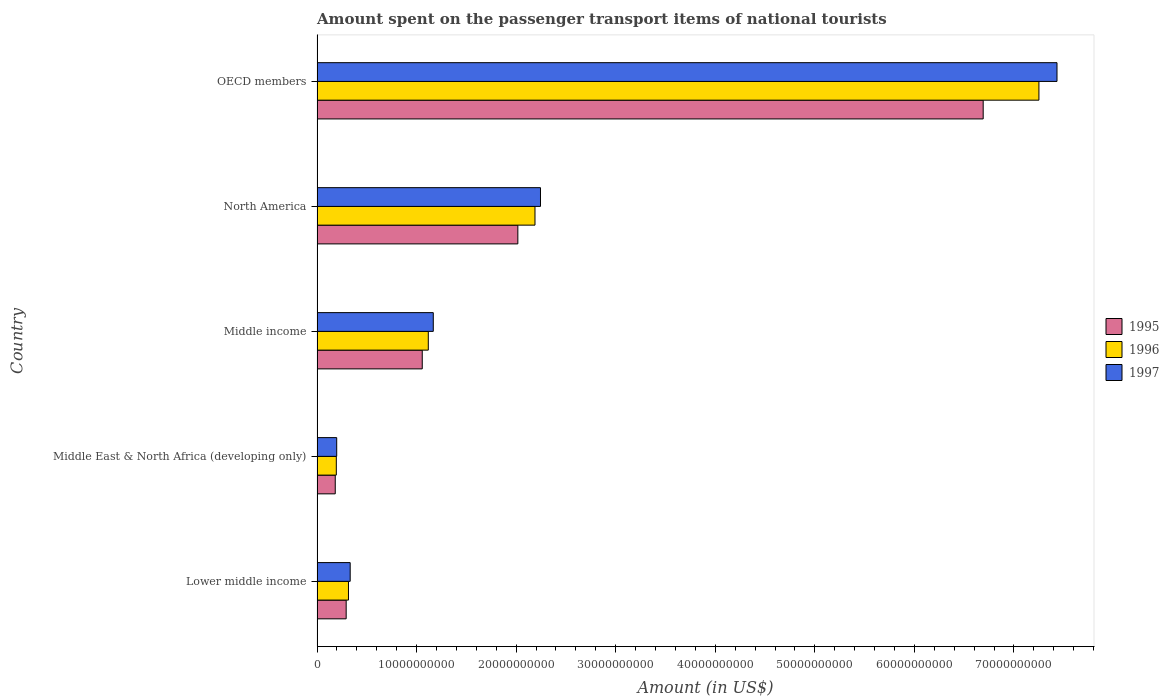How many groups of bars are there?
Your response must be concise. 5. Are the number of bars on each tick of the Y-axis equal?
Make the answer very short. Yes. How many bars are there on the 1st tick from the top?
Your answer should be very brief. 3. How many bars are there on the 5th tick from the bottom?
Give a very brief answer. 3. What is the label of the 5th group of bars from the top?
Offer a terse response. Lower middle income. In how many cases, is the number of bars for a given country not equal to the number of legend labels?
Make the answer very short. 0. What is the amount spent on the passenger transport items of national tourists in 1996 in North America?
Keep it short and to the point. 2.19e+1. Across all countries, what is the maximum amount spent on the passenger transport items of national tourists in 1997?
Ensure brevity in your answer.  7.43e+1. Across all countries, what is the minimum amount spent on the passenger transport items of national tourists in 1996?
Offer a very short reply. 1.94e+09. In which country was the amount spent on the passenger transport items of national tourists in 1997 maximum?
Your response must be concise. OECD members. In which country was the amount spent on the passenger transport items of national tourists in 1997 minimum?
Your answer should be very brief. Middle East & North Africa (developing only). What is the total amount spent on the passenger transport items of national tourists in 1997 in the graph?
Make the answer very short. 1.14e+11. What is the difference between the amount spent on the passenger transport items of national tourists in 1995 in Lower middle income and that in Middle income?
Your answer should be compact. -7.64e+09. What is the difference between the amount spent on the passenger transport items of national tourists in 1997 in Middle income and the amount spent on the passenger transport items of national tourists in 1996 in North America?
Give a very brief answer. -1.02e+1. What is the average amount spent on the passenger transport items of national tourists in 1996 per country?
Ensure brevity in your answer.  2.21e+1. What is the difference between the amount spent on the passenger transport items of national tourists in 1996 and amount spent on the passenger transport items of national tourists in 1997 in Middle income?
Make the answer very short. -5.01e+08. What is the ratio of the amount spent on the passenger transport items of national tourists in 1995 in Middle East & North Africa (developing only) to that in OECD members?
Your answer should be compact. 0.03. Is the difference between the amount spent on the passenger transport items of national tourists in 1996 in Middle income and North America greater than the difference between the amount spent on the passenger transport items of national tourists in 1997 in Middle income and North America?
Provide a succinct answer. Yes. What is the difference between the highest and the second highest amount spent on the passenger transport items of national tourists in 1996?
Give a very brief answer. 5.06e+1. What is the difference between the highest and the lowest amount spent on the passenger transport items of national tourists in 1995?
Make the answer very short. 6.51e+1. What does the 2nd bar from the top in Lower middle income represents?
Your answer should be compact. 1996. What does the 3rd bar from the bottom in Lower middle income represents?
Your answer should be very brief. 1997. Is it the case that in every country, the sum of the amount spent on the passenger transport items of national tourists in 1997 and amount spent on the passenger transport items of national tourists in 1996 is greater than the amount spent on the passenger transport items of national tourists in 1995?
Your answer should be very brief. Yes. How many bars are there?
Your response must be concise. 15. Are all the bars in the graph horizontal?
Offer a very short reply. Yes. How many countries are there in the graph?
Provide a succinct answer. 5. What is the difference between two consecutive major ticks on the X-axis?
Offer a very short reply. 1.00e+1. Are the values on the major ticks of X-axis written in scientific E-notation?
Provide a short and direct response. No. Does the graph contain grids?
Give a very brief answer. No. Where does the legend appear in the graph?
Your answer should be very brief. Center right. How many legend labels are there?
Provide a short and direct response. 3. How are the legend labels stacked?
Your answer should be very brief. Vertical. What is the title of the graph?
Provide a succinct answer. Amount spent on the passenger transport items of national tourists. Does "2003" appear as one of the legend labels in the graph?
Keep it short and to the point. No. What is the Amount (in US$) of 1995 in Lower middle income?
Your answer should be very brief. 2.92e+09. What is the Amount (in US$) in 1996 in Lower middle income?
Give a very brief answer. 3.16e+09. What is the Amount (in US$) of 1997 in Lower middle income?
Provide a short and direct response. 3.33e+09. What is the Amount (in US$) in 1995 in Middle East & North Africa (developing only)?
Offer a very short reply. 1.83e+09. What is the Amount (in US$) in 1996 in Middle East & North Africa (developing only)?
Make the answer very short. 1.94e+09. What is the Amount (in US$) in 1997 in Middle East & North Africa (developing only)?
Provide a short and direct response. 1.97e+09. What is the Amount (in US$) of 1995 in Middle income?
Provide a short and direct response. 1.06e+1. What is the Amount (in US$) in 1996 in Middle income?
Offer a terse response. 1.12e+1. What is the Amount (in US$) of 1997 in Middle income?
Provide a short and direct response. 1.17e+1. What is the Amount (in US$) in 1995 in North America?
Provide a succinct answer. 2.02e+1. What is the Amount (in US$) in 1996 in North America?
Your response must be concise. 2.19e+1. What is the Amount (in US$) of 1997 in North America?
Your response must be concise. 2.24e+1. What is the Amount (in US$) in 1995 in OECD members?
Your answer should be compact. 6.69e+1. What is the Amount (in US$) in 1996 in OECD members?
Give a very brief answer. 7.25e+1. What is the Amount (in US$) in 1997 in OECD members?
Provide a succinct answer. 7.43e+1. Across all countries, what is the maximum Amount (in US$) of 1995?
Keep it short and to the point. 6.69e+1. Across all countries, what is the maximum Amount (in US$) in 1996?
Make the answer very short. 7.25e+1. Across all countries, what is the maximum Amount (in US$) of 1997?
Provide a short and direct response. 7.43e+1. Across all countries, what is the minimum Amount (in US$) in 1995?
Offer a terse response. 1.83e+09. Across all countries, what is the minimum Amount (in US$) of 1996?
Give a very brief answer. 1.94e+09. Across all countries, what is the minimum Amount (in US$) in 1997?
Provide a succinct answer. 1.97e+09. What is the total Amount (in US$) in 1995 in the graph?
Provide a short and direct response. 1.02e+11. What is the total Amount (in US$) of 1996 in the graph?
Your answer should be very brief. 1.11e+11. What is the total Amount (in US$) in 1997 in the graph?
Offer a very short reply. 1.14e+11. What is the difference between the Amount (in US$) of 1995 in Lower middle income and that in Middle East & North Africa (developing only)?
Give a very brief answer. 1.10e+09. What is the difference between the Amount (in US$) in 1996 in Lower middle income and that in Middle East & North Africa (developing only)?
Provide a succinct answer. 1.22e+09. What is the difference between the Amount (in US$) in 1997 in Lower middle income and that in Middle East & North Africa (developing only)?
Give a very brief answer. 1.35e+09. What is the difference between the Amount (in US$) in 1995 in Lower middle income and that in Middle income?
Provide a short and direct response. -7.64e+09. What is the difference between the Amount (in US$) of 1996 in Lower middle income and that in Middle income?
Your response must be concise. -8.02e+09. What is the difference between the Amount (in US$) of 1997 in Lower middle income and that in Middle income?
Your answer should be very brief. -8.35e+09. What is the difference between the Amount (in US$) in 1995 in Lower middle income and that in North America?
Make the answer very short. -1.72e+1. What is the difference between the Amount (in US$) of 1996 in Lower middle income and that in North America?
Ensure brevity in your answer.  -1.87e+1. What is the difference between the Amount (in US$) in 1997 in Lower middle income and that in North America?
Make the answer very short. -1.91e+1. What is the difference between the Amount (in US$) in 1995 in Lower middle income and that in OECD members?
Your response must be concise. -6.40e+1. What is the difference between the Amount (in US$) of 1996 in Lower middle income and that in OECD members?
Ensure brevity in your answer.  -6.94e+1. What is the difference between the Amount (in US$) in 1997 in Lower middle income and that in OECD members?
Keep it short and to the point. -7.10e+1. What is the difference between the Amount (in US$) in 1995 in Middle East & North Africa (developing only) and that in Middle income?
Your answer should be compact. -8.74e+09. What is the difference between the Amount (in US$) in 1996 in Middle East & North Africa (developing only) and that in Middle income?
Ensure brevity in your answer.  -9.24e+09. What is the difference between the Amount (in US$) of 1997 in Middle East & North Africa (developing only) and that in Middle income?
Offer a very short reply. -9.70e+09. What is the difference between the Amount (in US$) in 1995 in Middle East & North Africa (developing only) and that in North America?
Offer a terse response. -1.83e+1. What is the difference between the Amount (in US$) of 1996 in Middle East & North Africa (developing only) and that in North America?
Ensure brevity in your answer.  -2.00e+1. What is the difference between the Amount (in US$) of 1997 in Middle East & North Africa (developing only) and that in North America?
Your answer should be compact. -2.05e+1. What is the difference between the Amount (in US$) of 1995 in Middle East & North Africa (developing only) and that in OECD members?
Offer a very short reply. -6.51e+1. What is the difference between the Amount (in US$) in 1996 in Middle East & North Africa (developing only) and that in OECD members?
Provide a short and direct response. -7.06e+1. What is the difference between the Amount (in US$) of 1997 in Middle East & North Africa (developing only) and that in OECD members?
Your answer should be compact. -7.24e+1. What is the difference between the Amount (in US$) of 1995 in Middle income and that in North America?
Ensure brevity in your answer.  -9.60e+09. What is the difference between the Amount (in US$) in 1996 in Middle income and that in North America?
Your answer should be very brief. -1.07e+1. What is the difference between the Amount (in US$) in 1997 in Middle income and that in North America?
Your answer should be compact. -1.08e+1. What is the difference between the Amount (in US$) in 1995 in Middle income and that in OECD members?
Your answer should be compact. -5.63e+1. What is the difference between the Amount (in US$) in 1996 in Middle income and that in OECD members?
Your answer should be very brief. -6.13e+1. What is the difference between the Amount (in US$) of 1997 in Middle income and that in OECD members?
Make the answer very short. -6.27e+1. What is the difference between the Amount (in US$) in 1995 in North America and that in OECD members?
Keep it short and to the point. -4.67e+1. What is the difference between the Amount (in US$) of 1996 in North America and that in OECD members?
Provide a succinct answer. -5.06e+1. What is the difference between the Amount (in US$) of 1997 in North America and that in OECD members?
Keep it short and to the point. -5.19e+1. What is the difference between the Amount (in US$) of 1995 in Lower middle income and the Amount (in US$) of 1996 in Middle East & North Africa (developing only)?
Make the answer very short. 9.90e+08. What is the difference between the Amount (in US$) in 1995 in Lower middle income and the Amount (in US$) in 1997 in Middle East & North Africa (developing only)?
Give a very brief answer. 9.50e+08. What is the difference between the Amount (in US$) in 1996 in Lower middle income and the Amount (in US$) in 1997 in Middle East & North Africa (developing only)?
Give a very brief answer. 1.18e+09. What is the difference between the Amount (in US$) of 1995 in Lower middle income and the Amount (in US$) of 1996 in Middle income?
Provide a short and direct response. -8.25e+09. What is the difference between the Amount (in US$) in 1995 in Lower middle income and the Amount (in US$) in 1997 in Middle income?
Ensure brevity in your answer.  -8.75e+09. What is the difference between the Amount (in US$) of 1996 in Lower middle income and the Amount (in US$) of 1997 in Middle income?
Give a very brief answer. -8.52e+09. What is the difference between the Amount (in US$) in 1995 in Lower middle income and the Amount (in US$) in 1996 in North America?
Offer a very short reply. -1.90e+1. What is the difference between the Amount (in US$) of 1995 in Lower middle income and the Amount (in US$) of 1997 in North America?
Your answer should be very brief. -1.95e+1. What is the difference between the Amount (in US$) in 1996 in Lower middle income and the Amount (in US$) in 1997 in North America?
Your answer should be compact. -1.93e+1. What is the difference between the Amount (in US$) in 1995 in Lower middle income and the Amount (in US$) in 1996 in OECD members?
Make the answer very short. -6.96e+1. What is the difference between the Amount (in US$) of 1995 in Lower middle income and the Amount (in US$) of 1997 in OECD members?
Make the answer very short. -7.14e+1. What is the difference between the Amount (in US$) in 1996 in Lower middle income and the Amount (in US$) in 1997 in OECD members?
Give a very brief answer. -7.12e+1. What is the difference between the Amount (in US$) of 1995 in Middle East & North Africa (developing only) and the Amount (in US$) of 1996 in Middle income?
Provide a succinct answer. -9.35e+09. What is the difference between the Amount (in US$) in 1995 in Middle East & North Africa (developing only) and the Amount (in US$) in 1997 in Middle income?
Ensure brevity in your answer.  -9.85e+09. What is the difference between the Amount (in US$) of 1996 in Middle East & North Africa (developing only) and the Amount (in US$) of 1997 in Middle income?
Your answer should be very brief. -9.74e+09. What is the difference between the Amount (in US$) in 1995 in Middle East & North Africa (developing only) and the Amount (in US$) in 1996 in North America?
Give a very brief answer. -2.01e+1. What is the difference between the Amount (in US$) in 1995 in Middle East & North Africa (developing only) and the Amount (in US$) in 1997 in North America?
Keep it short and to the point. -2.06e+1. What is the difference between the Amount (in US$) in 1996 in Middle East & North Africa (developing only) and the Amount (in US$) in 1997 in North America?
Your answer should be very brief. -2.05e+1. What is the difference between the Amount (in US$) of 1995 in Middle East & North Africa (developing only) and the Amount (in US$) of 1996 in OECD members?
Ensure brevity in your answer.  -7.07e+1. What is the difference between the Amount (in US$) of 1995 in Middle East & North Africa (developing only) and the Amount (in US$) of 1997 in OECD members?
Your answer should be very brief. -7.25e+1. What is the difference between the Amount (in US$) in 1996 in Middle East & North Africa (developing only) and the Amount (in US$) in 1997 in OECD members?
Make the answer very short. -7.24e+1. What is the difference between the Amount (in US$) in 1995 in Middle income and the Amount (in US$) in 1996 in North America?
Offer a very short reply. -1.13e+1. What is the difference between the Amount (in US$) in 1995 in Middle income and the Amount (in US$) in 1997 in North America?
Your response must be concise. -1.19e+1. What is the difference between the Amount (in US$) in 1996 in Middle income and the Amount (in US$) in 1997 in North America?
Your answer should be compact. -1.13e+1. What is the difference between the Amount (in US$) of 1995 in Middle income and the Amount (in US$) of 1996 in OECD members?
Offer a terse response. -6.19e+1. What is the difference between the Amount (in US$) of 1995 in Middle income and the Amount (in US$) of 1997 in OECD members?
Make the answer very short. -6.38e+1. What is the difference between the Amount (in US$) in 1996 in Middle income and the Amount (in US$) in 1997 in OECD members?
Your answer should be compact. -6.32e+1. What is the difference between the Amount (in US$) in 1995 in North America and the Amount (in US$) in 1996 in OECD members?
Keep it short and to the point. -5.23e+1. What is the difference between the Amount (in US$) in 1995 in North America and the Amount (in US$) in 1997 in OECD members?
Give a very brief answer. -5.42e+1. What is the difference between the Amount (in US$) in 1996 in North America and the Amount (in US$) in 1997 in OECD members?
Provide a short and direct response. -5.24e+1. What is the average Amount (in US$) of 1995 per country?
Your response must be concise. 2.05e+1. What is the average Amount (in US$) in 1996 per country?
Provide a succinct answer. 2.21e+1. What is the average Amount (in US$) in 1997 per country?
Your response must be concise. 2.27e+1. What is the difference between the Amount (in US$) of 1995 and Amount (in US$) of 1996 in Lower middle income?
Your response must be concise. -2.31e+08. What is the difference between the Amount (in US$) of 1995 and Amount (in US$) of 1997 in Lower middle income?
Give a very brief answer. -4.03e+08. What is the difference between the Amount (in US$) of 1996 and Amount (in US$) of 1997 in Lower middle income?
Provide a short and direct response. -1.73e+08. What is the difference between the Amount (in US$) of 1995 and Amount (in US$) of 1996 in Middle East & North Africa (developing only)?
Your answer should be compact. -1.08e+08. What is the difference between the Amount (in US$) in 1995 and Amount (in US$) in 1997 in Middle East & North Africa (developing only)?
Your response must be concise. -1.47e+08. What is the difference between the Amount (in US$) in 1996 and Amount (in US$) in 1997 in Middle East & North Africa (developing only)?
Your response must be concise. -3.92e+07. What is the difference between the Amount (in US$) of 1995 and Amount (in US$) of 1996 in Middle income?
Ensure brevity in your answer.  -6.08e+08. What is the difference between the Amount (in US$) in 1995 and Amount (in US$) in 1997 in Middle income?
Give a very brief answer. -1.11e+09. What is the difference between the Amount (in US$) in 1996 and Amount (in US$) in 1997 in Middle income?
Provide a succinct answer. -5.01e+08. What is the difference between the Amount (in US$) of 1995 and Amount (in US$) of 1996 in North America?
Ensure brevity in your answer.  -1.72e+09. What is the difference between the Amount (in US$) of 1995 and Amount (in US$) of 1997 in North America?
Provide a short and direct response. -2.28e+09. What is the difference between the Amount (in US$) in 1996 and Amount (in US$) in 1997 in North America?
Offer a terse response. -5.53e+08. What is the difference between the Amount (in US$) in 1995 and Amount (in US$) in 1996 in OECD members?
Provide a short and direct response. -5.60e+09. What is the difference between the Amount (in US$) of 1995 and Amount (in US$) of 1997 in OECD members?
Offer a terse response. -7.41e+09. What is the difference between the Amount (in US$) of 1996 and Amount (in US$) of 1997 in OECD members?
Your answer should be very brief. -1.82e+09. What is the ratio of the Amount (in US$) of 1995 in Lower middle income to that in Middle East & North Africa (developing only)?
Your answer should be very brief. 1.6. What is the ratio of the Amount (in US$) of 1996 in Lower middle income to that in Middle East & North Africa (developing only)?
Offer a very short reply. 1.63. What is the ratio of the Amount (in US$) in 1997 in Lower middle income to that in Middle East & North Africa (developing only)?
Give a very brief answer. 1.69. What is the ratio of the Amount (in US$) of 1995 in Lower middle income to that in Middle income?
Ensure brevity in your answer.  0.28. What is the ratio of the Amount (in US$) in 1996 in Lower middle income to that in Middle income?
Provide a succinct answer. 0.28. What is the ratio of the Amount (in US$) in 1997 in Lower middle income to that in Middle income?
Provide a succinct answer. 0.29. What is the ratio of the Amount (in US$) of 1995 in Lower middle income to that in North America?
Give a very brief answer. 0.14. What is the ratio of the Amount (in US$) of 1996 in Lower middle income to that in North America?
Provide a succinct answer. 0.14. What is the ratio of the Amount (in US$) of 1997 in Lower middle income to that in North America?
Offer a terse response. 0.15. What is the ratio of the Amount (in US$) of 1995 in Lower middle income to that in OECD members?
Keep it short and to the point. 0.04. What is the ratio of the Amount (in US$) of 1996 in Lower middle income to that in OECD members?
Offer a terse response. 0.04. What is the ratio of the Amount (in US$) of 1997 in Lower middle income to that in OECD members?
Ensure brevity in your answer.  0.04. What is the ratio of the Amount (in US$) of 1995 in Middle East & North Africa (developing only) to that in Middle income?
Provide a succinct answer. 0.17. What is the ratio of the Amount (in US$) in 1996 in Middle East & North Africa (developing only) to that in Middle income?
Your answer should be compact. 0.17. What is the ratio of the Amount (in US$) in 1997 in Middle East & North Africa (developing only) to that in Middle income?
Your answer should be compact. 0.17. What is the ratio of the Amount (in US$) of 1995 in Middle East & North Africa (developing only) to that in North America?
Offer a very short reply. 0.09. What is the ratio of the Amount (in US$) of 1996 in Middle East & North Africa (developing only) to that in North America?
Your answer should be very brief. 0.09. What is the ratio of the Amount (in US$) of 1997 in Middle East & North Africa (developing only) to that in North America?
Offer a very short reply. 0.09. What is the ratio of the Amount (in US$) of 1995 in Middle East & North Africa (developing only) to that in OECD members?
Make the answer very short. 0.03. What is the ratio of the Amount (in US$) of 1996 in Middle East & North Africa (developing only) to that in OECD members?
Keep it short and to the point. 0.03. What is the ratio of the Amount (in US$) of 1997 in Middle East & North Africa (developing only) to that in OECD members?
Ensure brevity in your answer.  0.03. What is the ratio of the Amount (in US$) of 1995 in Middle income to that in North America?
Keep it short and to the point. 0.52. What is the ratio of the Amount (in US$) in 1996 in Middle income to that in North America?
Provide a succinct answer. 0.51. What is the ratio of the Amount (in US$) in 1997 in Middle income to that in North America?
Ensure brevity in your answer.  0.52. What is the ratio of the Amount (in US$) in 1995 in Middle income to that in OECD members?
Ensure brevity in your answer.  0.16. What is the ratio of the Amount (in US$) of 1996 in Middle income to that in OECD members?
Provide a succinct answer. 0.15. What is the ratio of the Amount (in US$) of 1997 in Middle income to that in OECD members?
Keep it short and to the point. 0.16. What is the ratio of the Amount (in US$) of 1995 in North America to that in OECD members?
Ensure brevity in your answer.  0.3. What is the ratio of the Amount (in US$) in 1996 in North America to that in OECD members?
Ensure brevity in your answer.  0.3. What is the ratio of the Amount (in US$) of 1997 in North America to that in OECD members?
Your response must be concise. 0.3. What is the difference between the highest and the second highest Amount (in US$) in 1995?
Offer a very short reply. 4.67e+1. What is the difference between the highest and the second highest Amount (in US$) in 1996?
Ensure brevity in your answer.  5.06e+1. What is the difference between the highest and the second highest Amount (in US$) of 1997?
Your response must be concise. 5.19e+1. What is the difference between the highest and the lowest Amount (in US$) in 1995?
Provide a short and direct response. 6.51e+1. What is the difference between the highest and the lowest Amount (in US$) of 1996?
Keep it short and to the point. 7.06e+1. What is the difference between the highest and the lowest Amount (in US$) of 1997?
Your answer should be compact. 7.24e+1. 